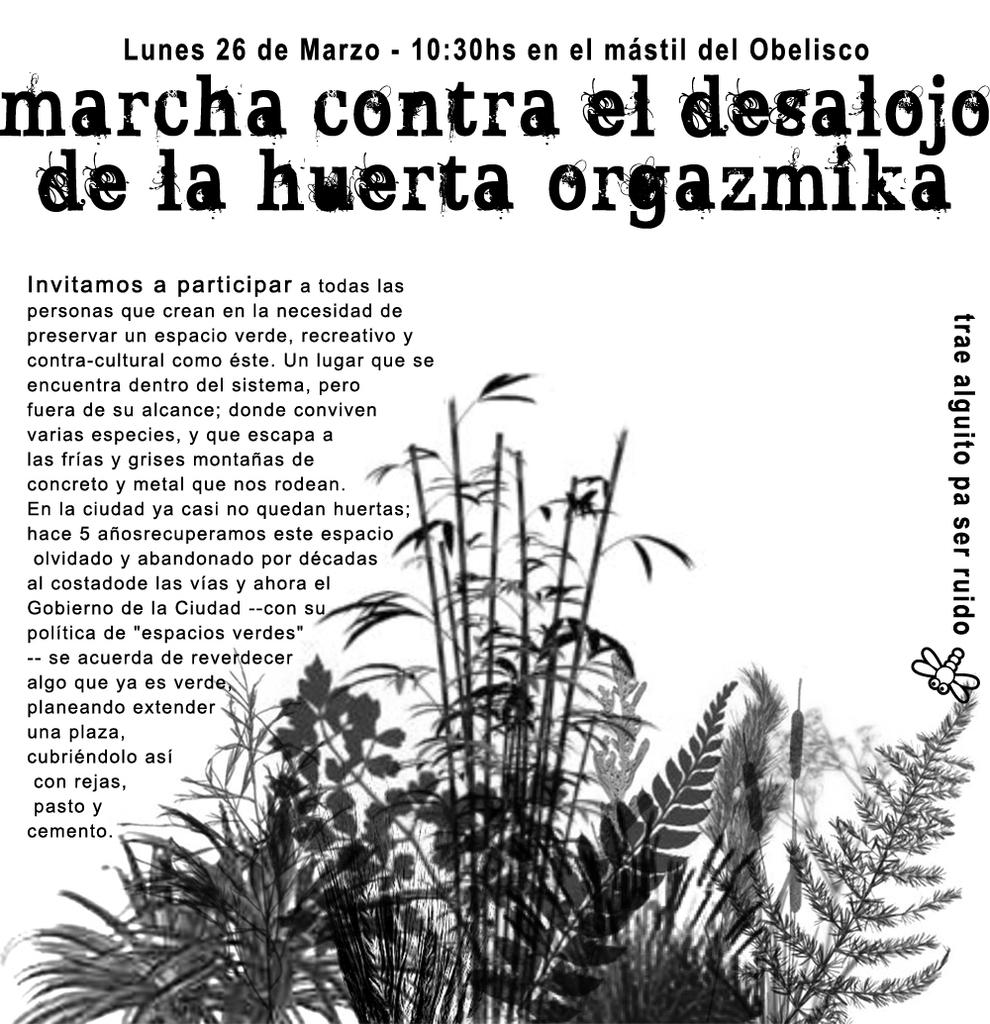What can be seen written in the image? There are words and numbers written in the image. What type of living organisms can be seen in the image? There is a depiction of plants and an insect in the image. What is the color of the background in the image? The background of the image is white. What health advice is the insect giving in the image? There is no indication in the image that the insect is giving health advice, as insects do not communicate in this manner. 